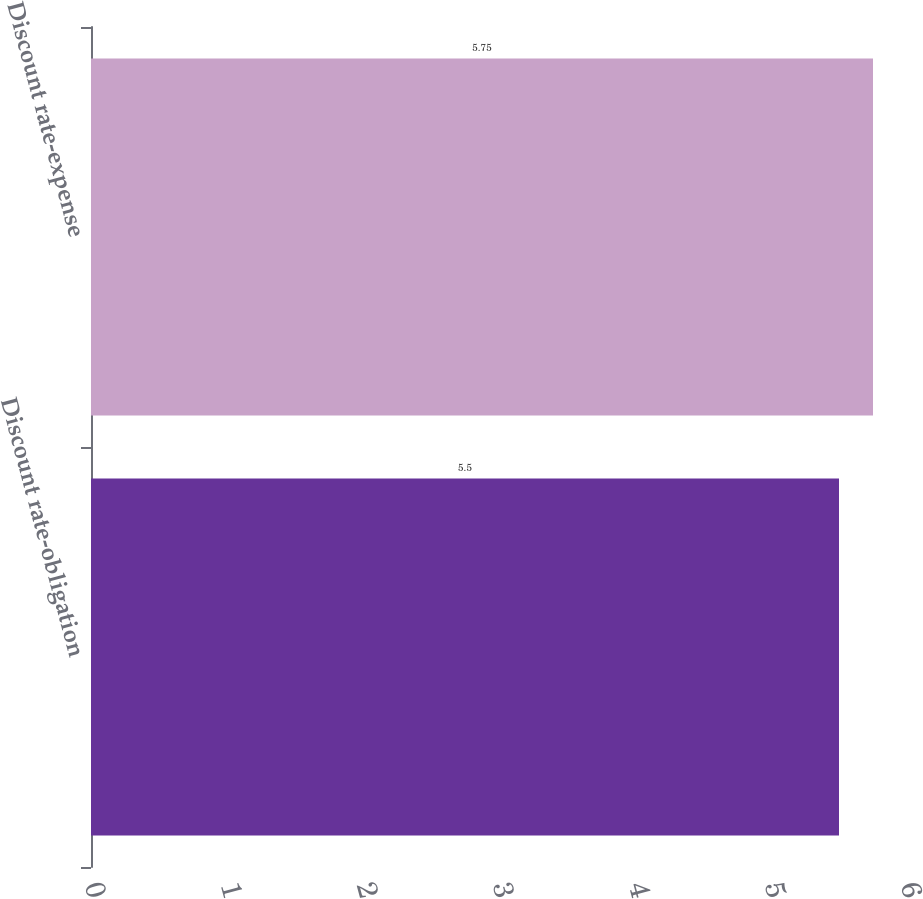Convert chart to OTSL. <chart><loc_0><loc_0><loc_500><loc_500><bar_chart><fcel>Discount rate-obligation<fcel>Discount rate-expense<nl><fcel>5.5<fcel>5.75<nl></chart> 